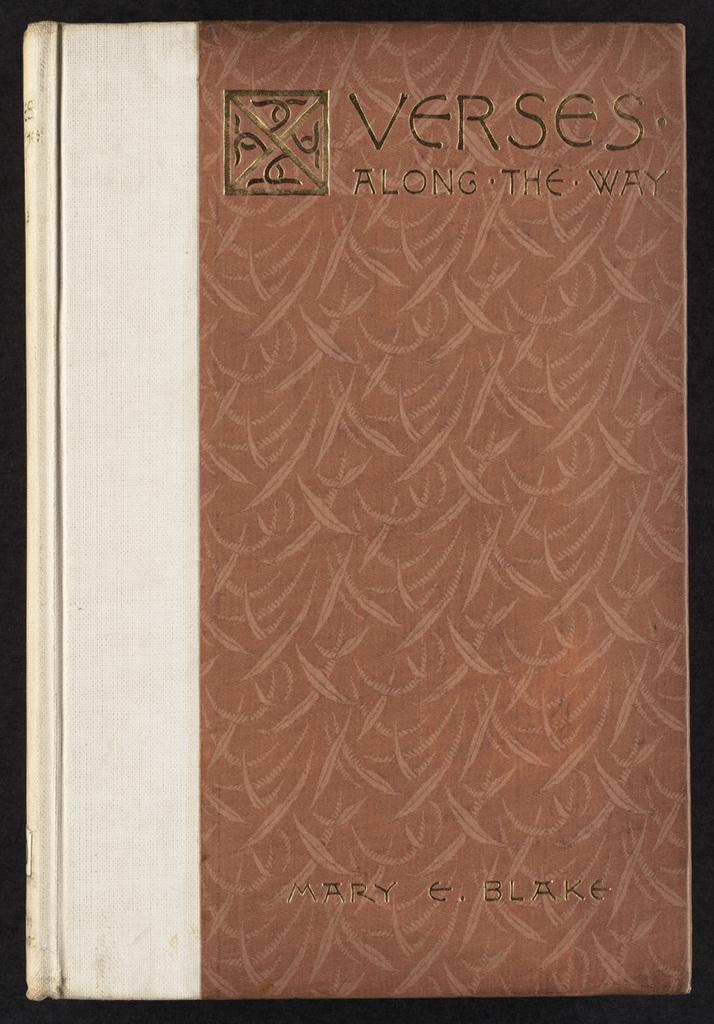Provide a one-sentence caption for the provided image. A hardcover copy of Verses Along the Way by Mary Blake. 